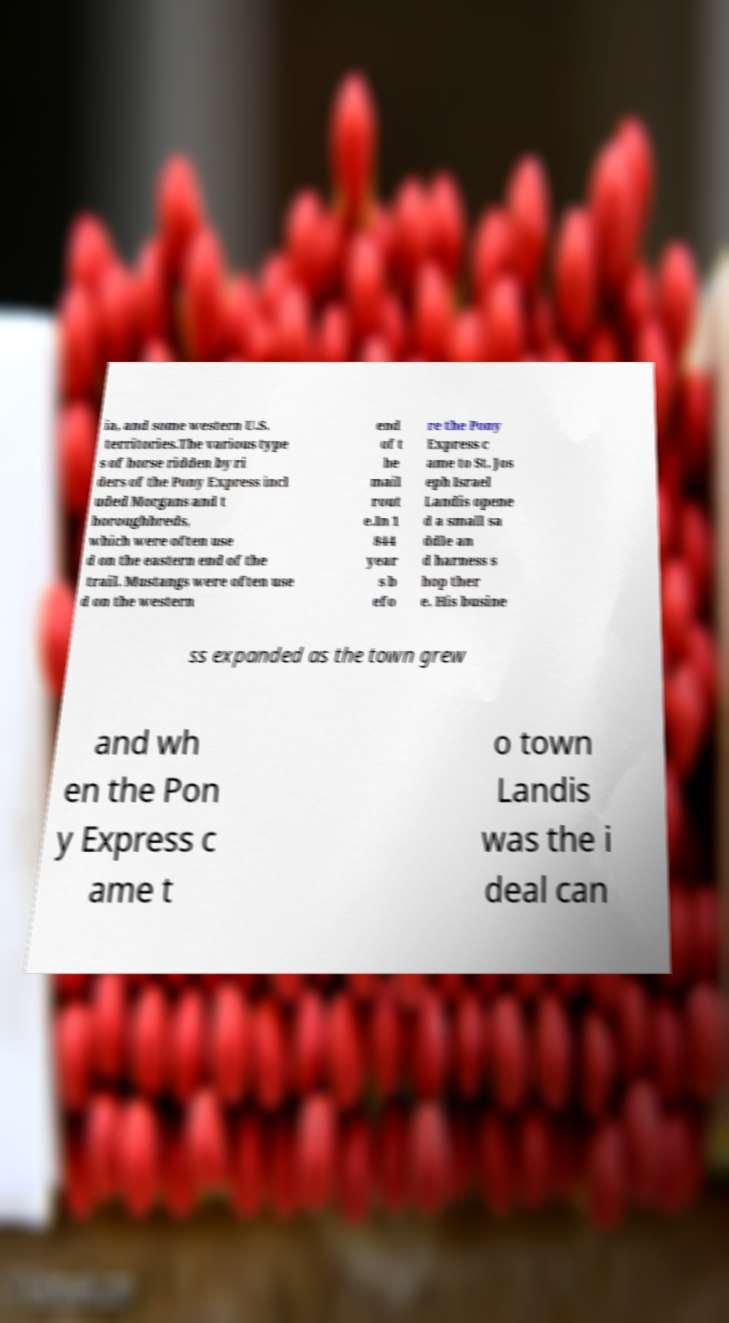Can you accurately transcribe the text from the provided image for me? ia, and some western U.S. territories.The various type s of horse ridden by ri ders of the Pony Express incl uded Morgans and t horoughbreds, which were often use d on the eastern end of the trail. Mustangs were often use d on the western end of t he mail rout e.In 1 844 year s b efo re the Pony Express c ame to St. Jos eph Israel Landis opene d a small sa ddle an d harness s hop ther e. His busine ss expanded as the town grew and wh en the Pon y Express c ame t o town Landis was the i deal can 